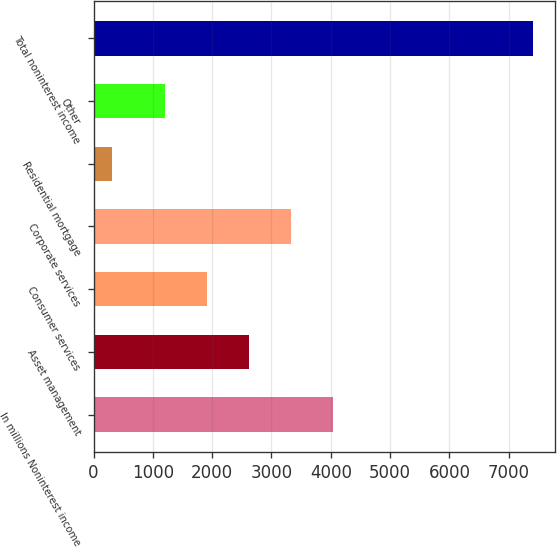Convert chart. <chart><loc_0><loc_0><loc_500><loc_500><bar_chart><fcel>In millions Noninterest income<fcel>Asset management<fcel>Consumer services<fcel>Corporate services<fcel>Residential mortgage<fcel>Other<fcel>Total noninterest income<nl><fcel>4043<fcel>2624<fcel>1914.5<fcel>3333.5<fcel>316<fcel>1205<fcel>7411<nl></chart> 